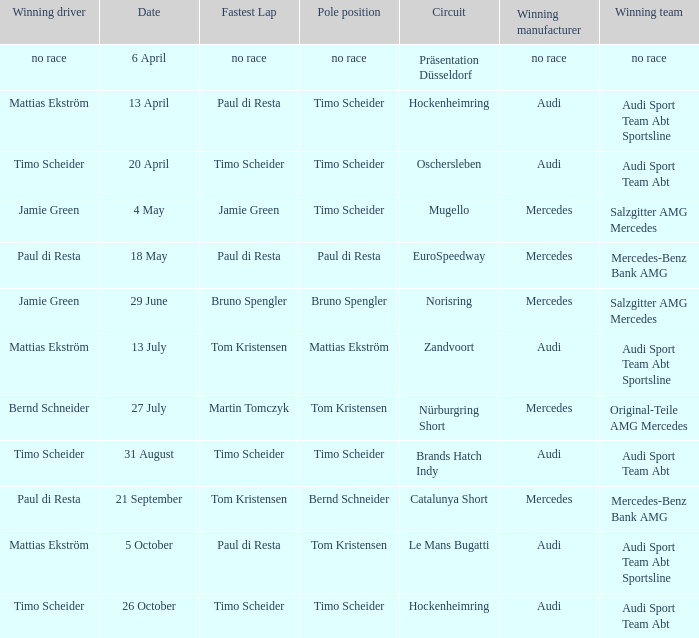What is the fastest lap of the Oschersleben circuit with Audi Sport Team ABT as the winning team? Timo Scheider. Parse the full table. {'header': ['Winning driver', 'Date', 'Fastest Lap', 'Pole position', 'Circuit', 'Winning manufacturer', 'Winning team'], 'rows': [['no race', '6 April', 'no race', 'no race', 'Präsentation Düsseldorf', 'no race', 'no race'], ['Mattias Ekström', '13 April', 'Paul di Resta', 'Timo Scheider', 'Hockenheimring', 'Audi', 'Audi Sport Team Abt Sportsline'], ['Timo Scheider', '20 April', 'Timo Scheider', 'Timo Scheider', 'Oschersleben', 'Audi', 'Audi Sport Team Abt'], ['Jamie Green', '4 May', 'Jamie Green', 'Timo Scheider', 'Mugello', 'Mercedes', 'Salzgitter AMG Mercedes'], ['Paul di Resta', '18 May', 'Paul di Resta', 'Paul di Resta', 'EuroSpeedway', 'Mercedes', 'Mercedes-Benz Bank AMG'], ['Jamie Green', '29 June', 'Bruno Spengler', 'Bruno Spengler', 'Norisring', 'Mercedes', 'Salzgitter AMG Mercedes'], ['Mattias Ekström', '13 July', 'Tom Kristensen', 'Mattias Ekström', 'Zandvoort', 'Audi', 'Audi Sport Team Abt Sportsline'], ['Bernd Schneider', '27 July', 'Martin Tomczyk', 'Tom Kristensen', 'Nürburgring Short', 'Mercedes', 'Original-Teile AMG Mercedes'], ['Timo Scheider', '31 August', 'Timo Scheider', 'Timo Scheider', 'Brands Hatch Indy', 'Audi', 'Audi Sport Team Abt'], ['Paul di Resta', '21 September', 'Tom Kristensen', 'Bernd Schneider', 'Catalunya Short', 'Mercedes', 'Mercedes-Benz Bank AMG'], ['Mattias Ekström', '5 October', 'Paul di Resta', 'Tom Kristensen', 'Le Mans Bugatti', 'Audi', 'Audi Sport Team Abt Sportsline'], ['Timo Scheider', '26 October', 'Timo Scheider', 'Timo Scheider', 'Hockenheimring', 'Audi', 'Audi Sport Team Abt']]} 